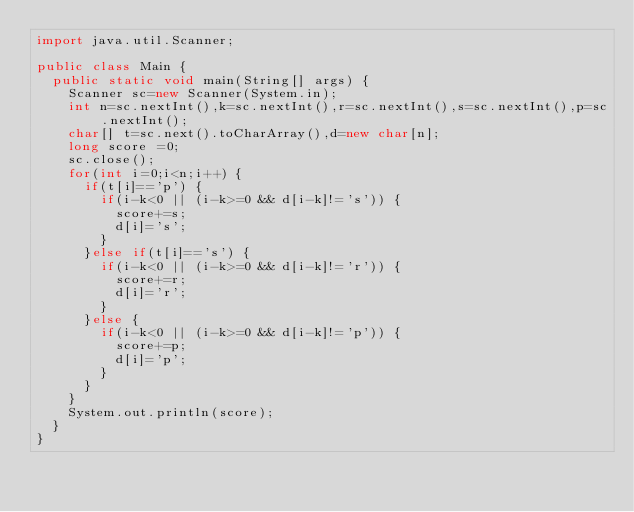<code> <loc_0><loc_0><loc_500><loc_500><_Java_>import java.util.Scanner;

public class Main {
	public static void main(String[] args) {
		Scanner sc=new Scanner(System.in);
		int n=sc.nextInt(),k=sc.nextInt(),r=sc.nextInt(),s=sc.nextInt(),p=sc.nextInt();
		char[] t=sc.next().toCharArray(),d=new char[n];
		long score =0;
		sc.close();
		for(int i=0;i<n;i++) {
			if(t[i]=='p') {
				if(i-k<0 || (i-k>=0 && d[i-k]!='s')) {
					score+=s;
					d[i]='s';
				}
			}else if(t[i]=='s') {
				if(i-k<0 || (i-k>=0 && d[i-k]!='r')) {
					score+=r;
					d[i]='r';
				}
			}else {
				if(i-k<0 || (i-k>=0 && d[i-k]!='p')) {
					score+=p;
					d[i]='p';
				}
			}
		}
		System.out.println(score);
	}
}</code> 